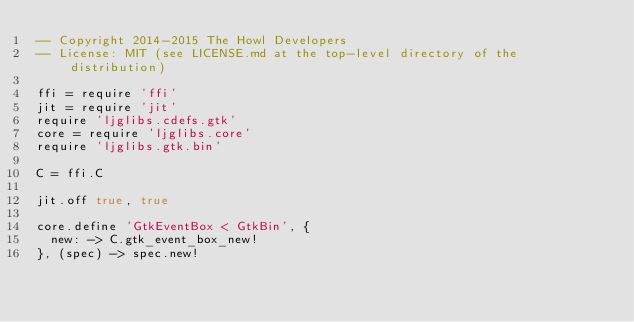<code> <loc_0><loc_0><loc_500><loc_500><_MoonScript_>-- Copyright 2014-2015 The Howl Developers
-- License: MIT (see LICENSE.md at the top-level directory of the distribution)

ffi = require 'ffi'
jit = require 'jit'
require 'ljglibs.cdefs.gtk'
core = require 'ljglibs.core'
require 'ljglibs.gtk.bin'

C = ffi.C

jit.off true, true

core.define 'GtkEventBox < GtkBin', {
  new: -> C.gtk_event_box_new!
}, (spec) -> spec.new!
</code> 